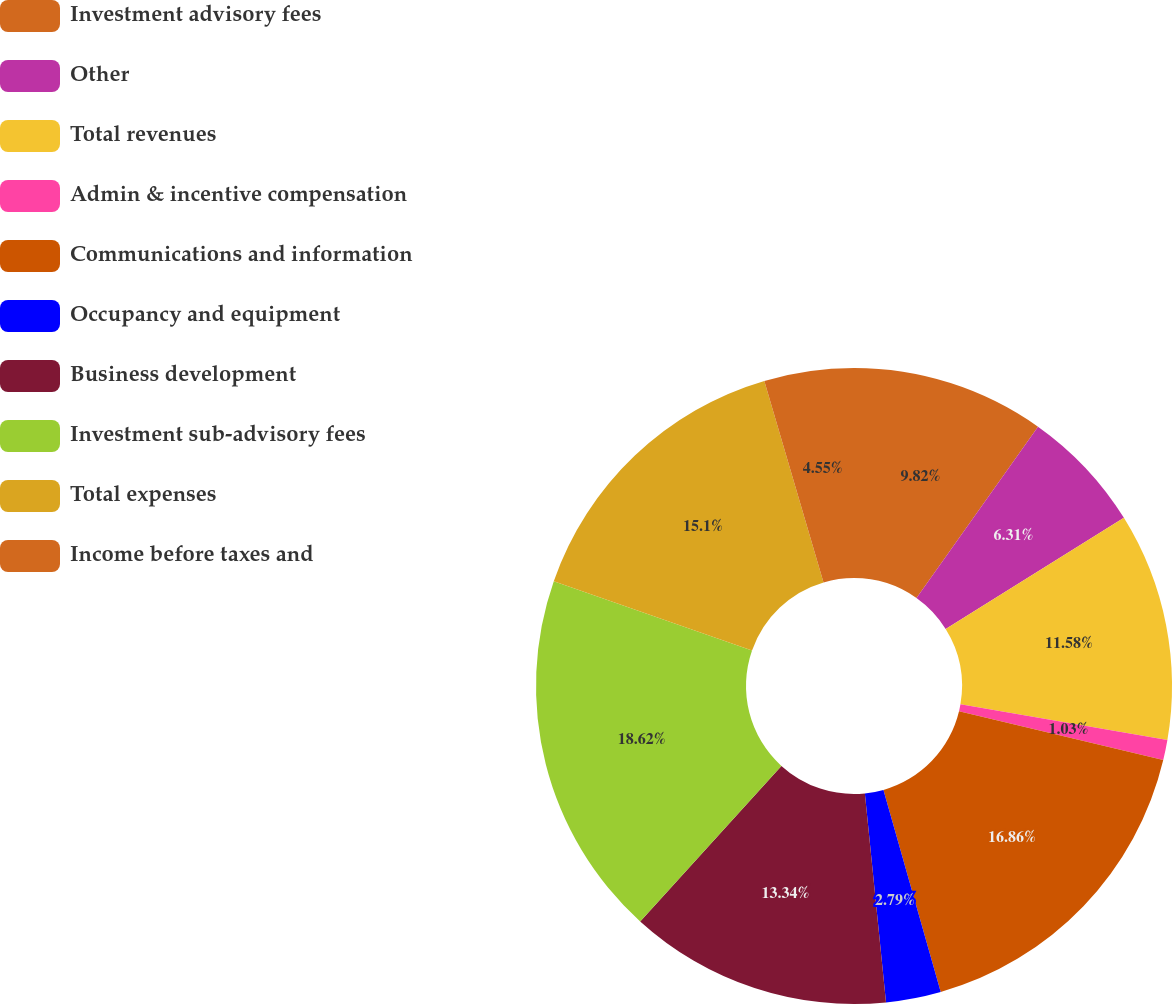Convert chart. <chart><loc_0><loc_0><loc_500><loc_500><pie_chart><fcel>Investment advisory fees<fcel>Other<fcel>Total revenues<fcel>Admin & incentive compensation<fcel>Communications and information<fcel>Occupancy and equipment<fcel>Business development<fcel>Investment sub-advisory fees<fcel>Total expenses<fcel>Income before taxes and<nl><fcel>9.82%<fcel>6.31%<fcel>11.58%<fcel>1.03%<fcel>16.86%<fcel>2.79%<fcel>13.34%<fcel>18.61%<fcel>15.1%<fcel>4.55%<nl></chart> 